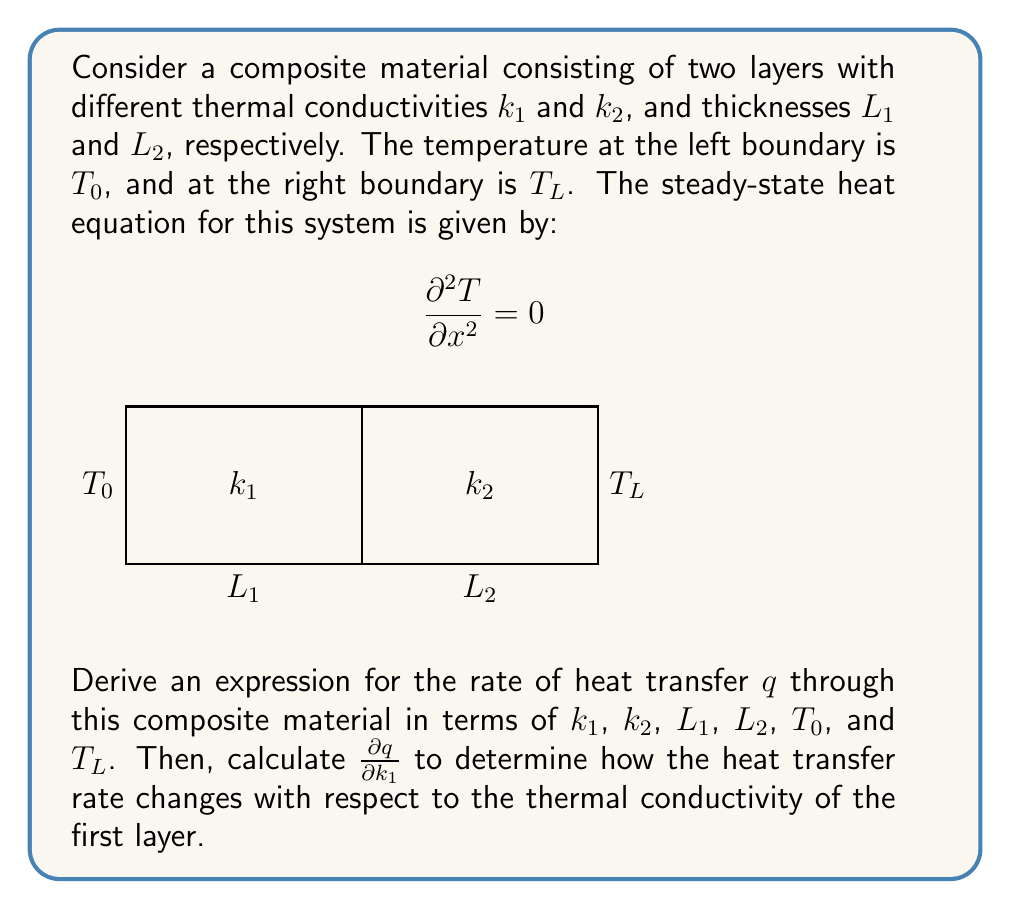What is the answer to this math problem? Let's approach this step-by-step:

1) In steady-state, the heat flux $q$ is constant throughout the material. For each layer, we can write:

   $$q = -k_1 \frac{dT_1}{dx} = -k_2 \frac{dT_2}{dx}$$

2) Integrating these equations over each layer:

   $$q = k_1 \frac{T_i - T_0}{L_1} = k_2 \frac{T_L - T_i}{L_2}$$

   where $T_i$ is the interface temperature.

3) Eliminating $T_i$, we get:

   $$q = \frac{T_L - T_0}{\frac{L_1}{k_1} + \frac{L_2}{k_2}}$$

4) This is our expression for the heat transfer rate. To find $\frac{\partial q}{\partial k_1}$, we use the quotient rule:

   $$\frac{\partial q}{\partial k_1} = \frac{(T_L - T_0) \cdot \frac{\partial}{\partial k_1}(\frac{L_1}{k_1} + \frac{L_2}{k_2}) - 0}{(\frac{L_1}{k_1} + \frac{L_2}{k_2})^2}$$

5) Simplifying:

   $$\frac{\partial q}{\partial k_1} = \frac{(T_L - T_0) \cdot (-\frac{L_1}{k_1^2})}{(\frac{L_1}{k_1} + \frac{L_2}{k_2})^2}$$

6) This can be further simplified to:

   $$\frac{\partial q}{\partial k_1} = \frac{q^2 L_1}{k_1^2 (T_L - T_0)}$$

This expression shows how the heat transfer rate changes with respect to the thermal conductivity of the first layer.
Answer: $\frac{\partial q}{\partial k_1} = \frac{q^2 L_1}{k_1^2 (T_L - T_0)}$ 